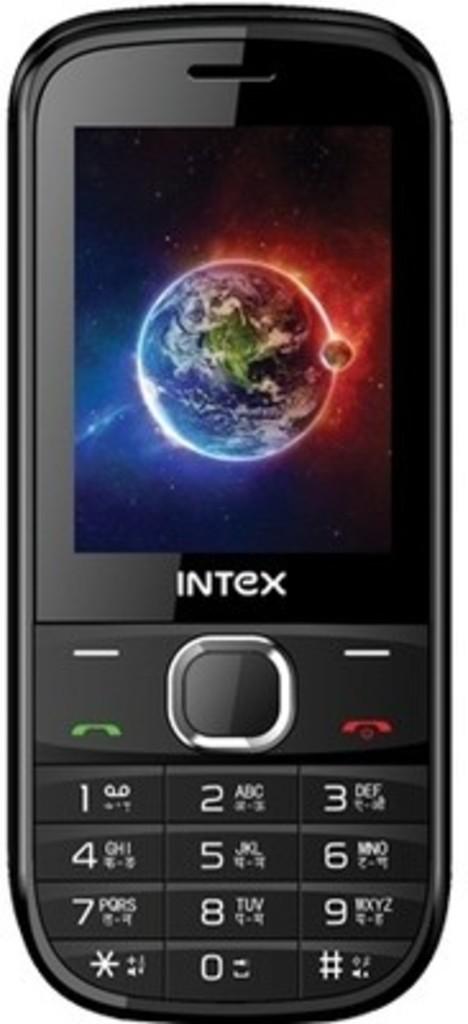What brand of phone is this?
Your response must be concise. Intex. 